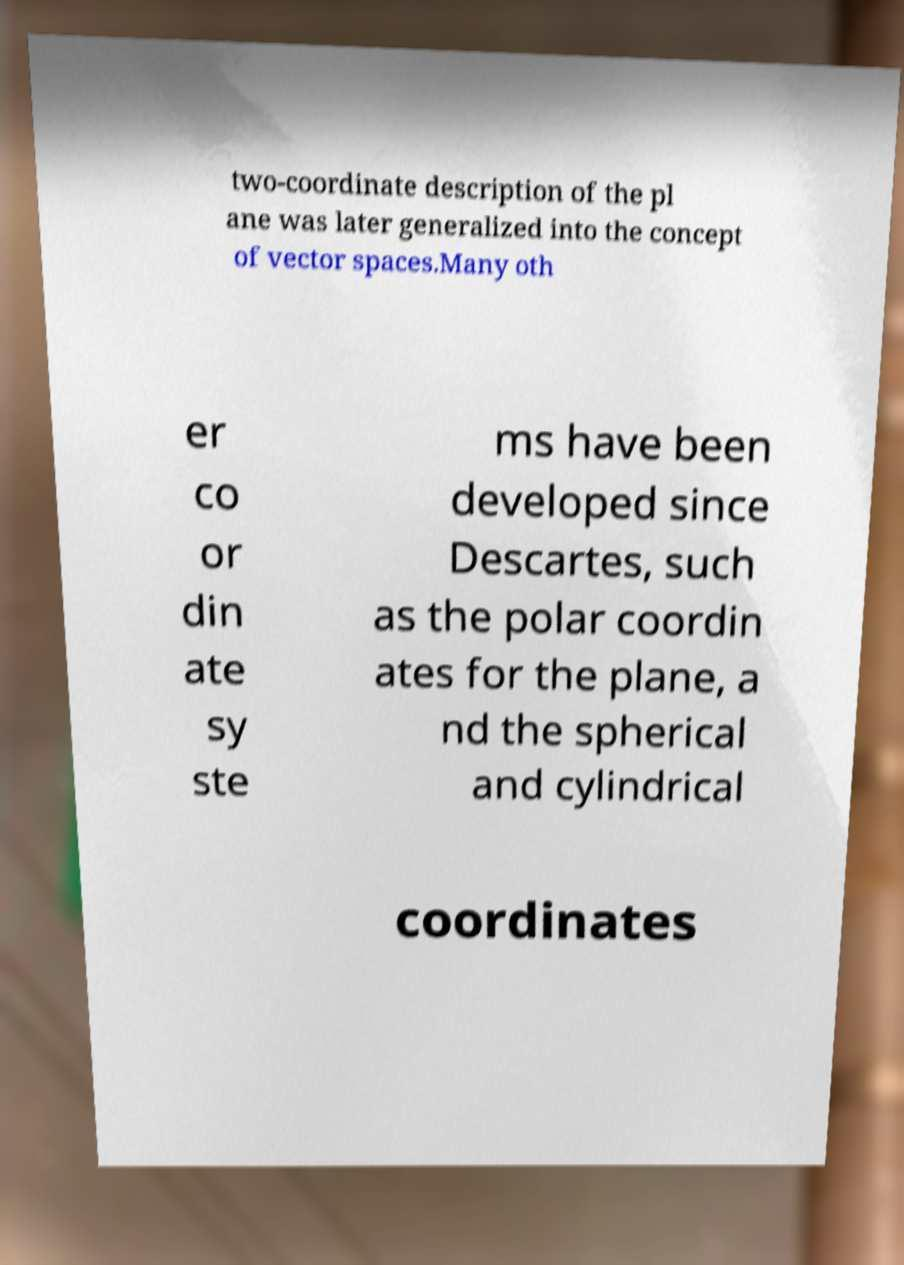Please read and relay the text visible in this image. What does it say? two-coordinate description of the pl ane was later generalized into the concept of vector spaces.Many oth er co or din ate sy ste ms have been developed since Descartes, such as the polar coordin ates for the plane, a nd the spherical and cylindrical coordinates 